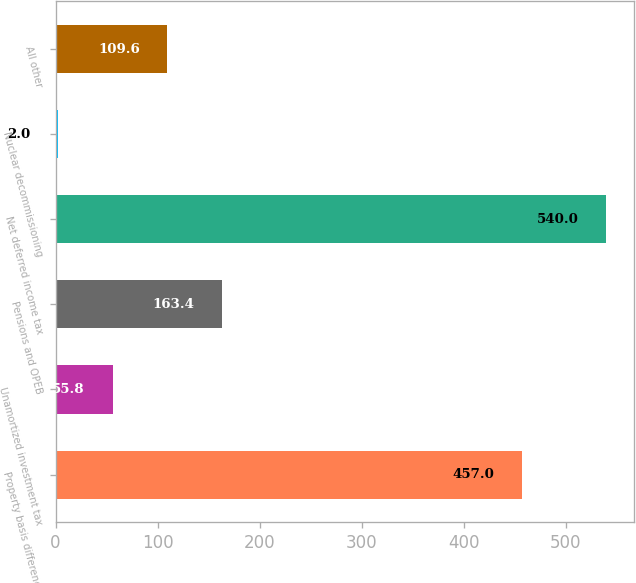Convert chart to OTSL. <chart><loc_0><loc_0><loc_500><loc_500><bar_chart><fcel>Property basis differences<fcel>Unamortized investment tax<fcel>Pensions and OPEB<fcel>Net deferred income tax<fcel>Nuclear decommissioning<fcel>All other<nl><fcel>457<fcel>55.8<fcel>163.4<fcel>540<fcel>2<fcel>109.6<nl></chart> 